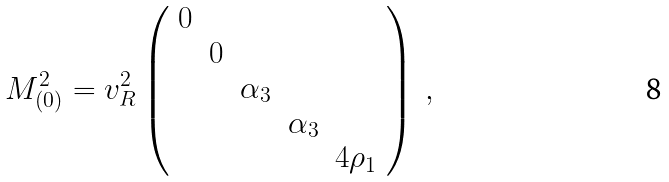Convert formula to latex. <formula><loc_0><loc_0><loc_500><loc_500>M ^ { 2 } _ { ( 0 ) } = v _ { R } ^ { 2 } \left ( \begin{array} { c c c c c } 0 & & & & \\ & 0 & & & \\ & & \alpha _ { 3 } & & \\ & & & \alpha _ { 3 } & \\ & & & & 4 \rho _ { 1 } \\ \end{array} \right ) \ ,</formula> 